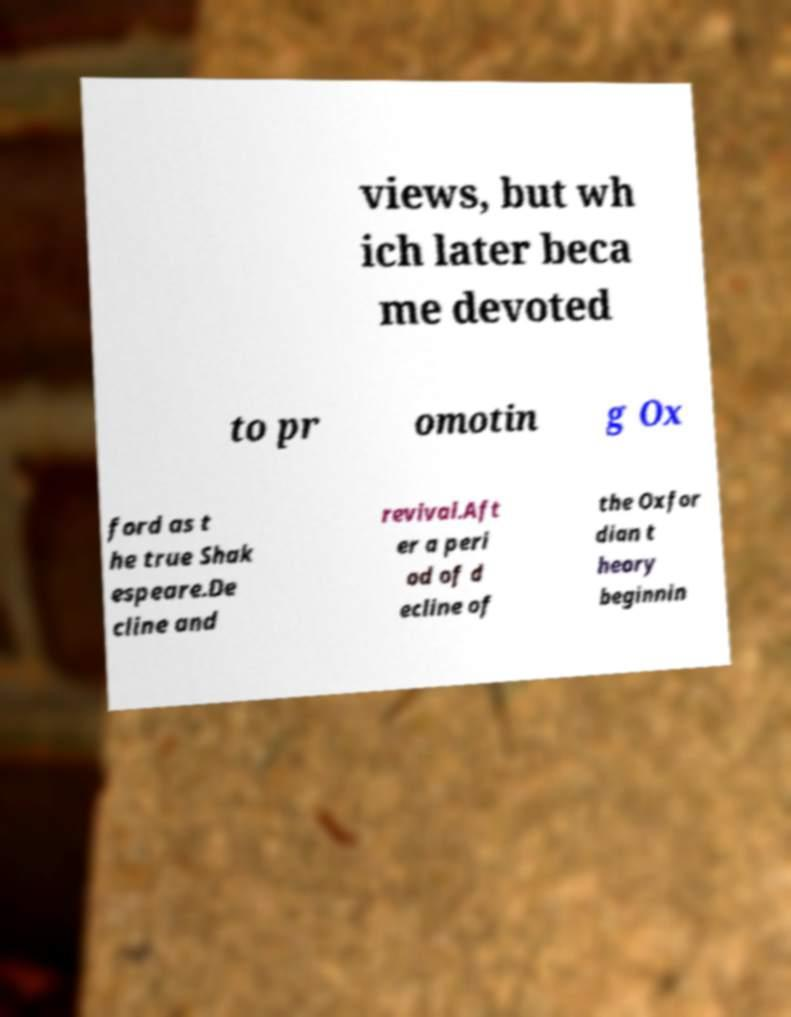Can you read and provide the text displayed in the image?This photo seems to have some interesting text. Can you extract and type it out for me? views, but wh ich later beca me devoted to pr omotin g Ox ford as t he true Shak espeare.De cline and revival.Aft er a peri od of d ecline of the Oxfor dian t heory beginnin 